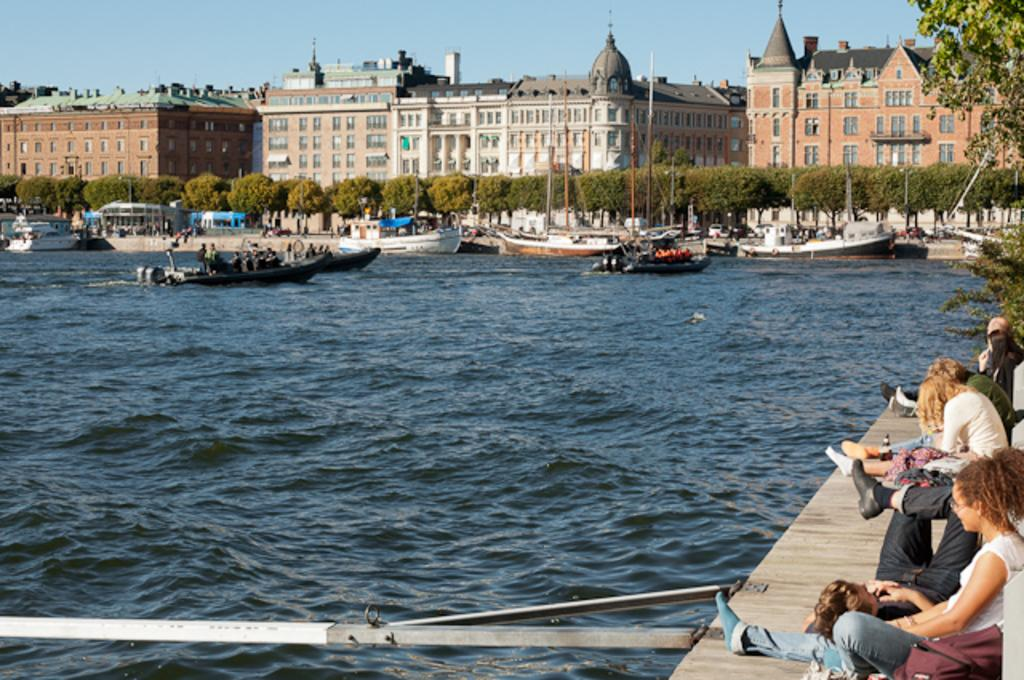What are the people in the image doing? There is a group of people sitting on a wooden path in the image. What can be seen near the people? There is an iron pole in the image. What is visible on the water in the image? Boats are visible on the water. What type of structures can be seen in the image? There are buildings with windows in the image. What type of vegetation is present in the image? Trees are present in the image. What color is the bath in the image? There is no bath present in the image. What attempt is being made by the people sitting on the wooden path? The image does not provide any information about an attempt being made by the people sitting on the wooden path. 